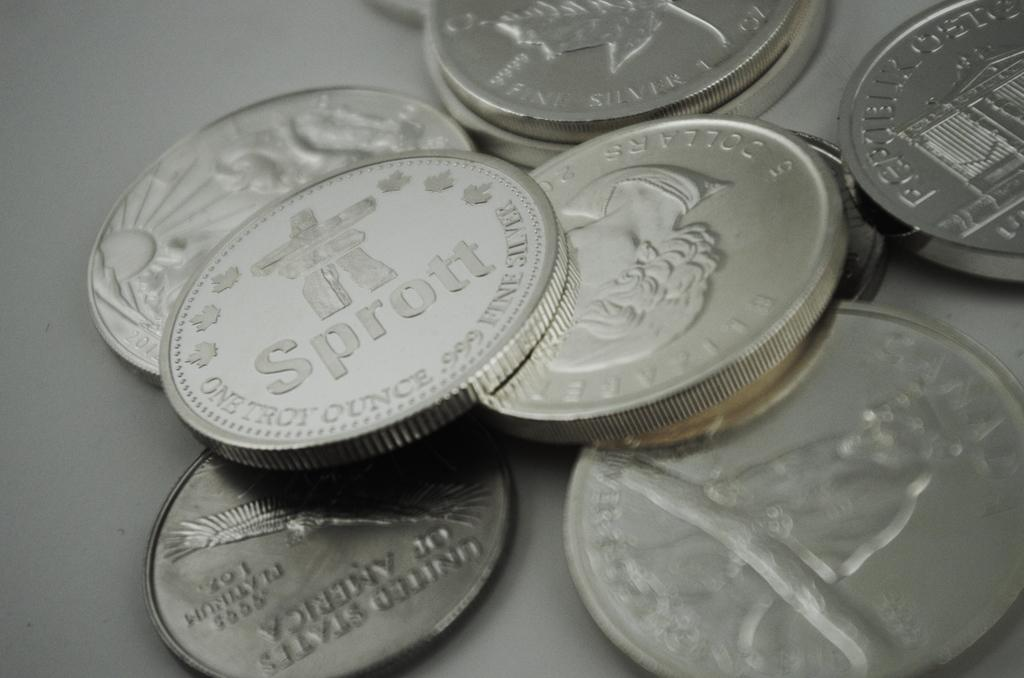<image>
Provide a brief description of the given image. Various coins scattered on a table and one says Sprott 